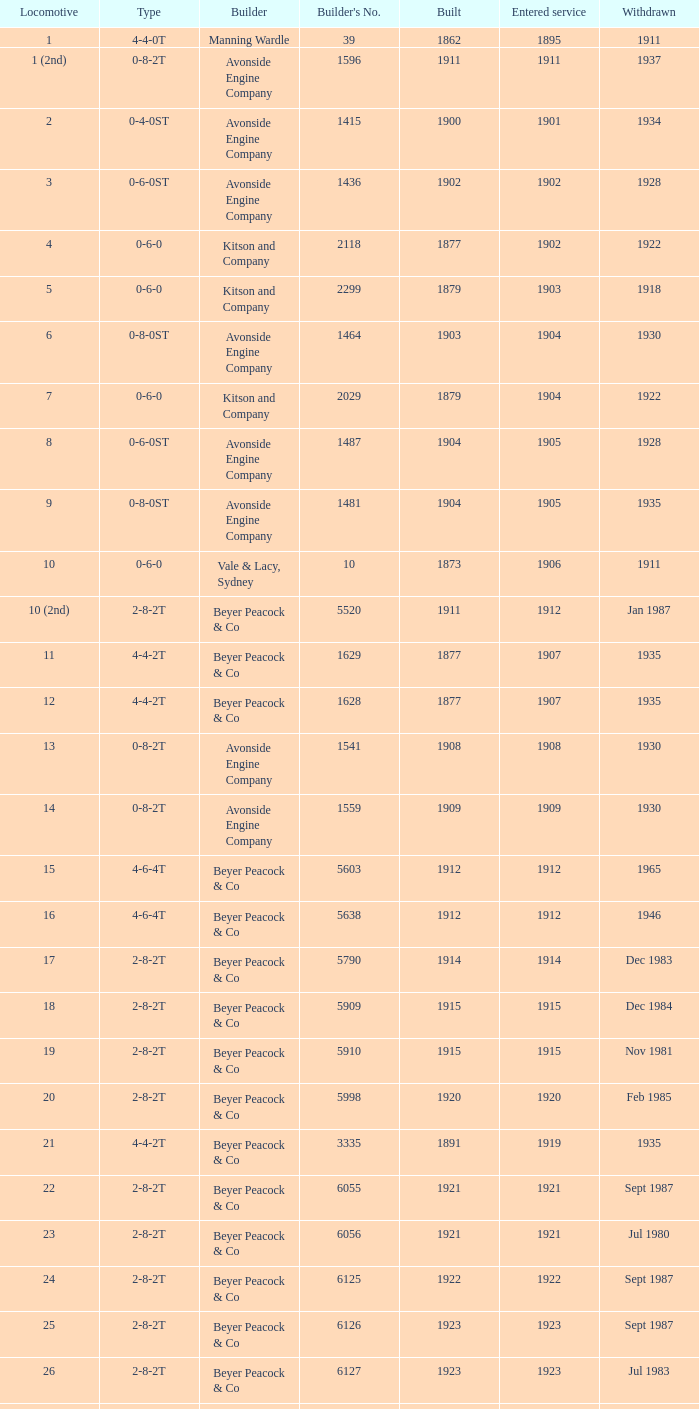Over how many years did 13 locomotives come into service? 1.0. 